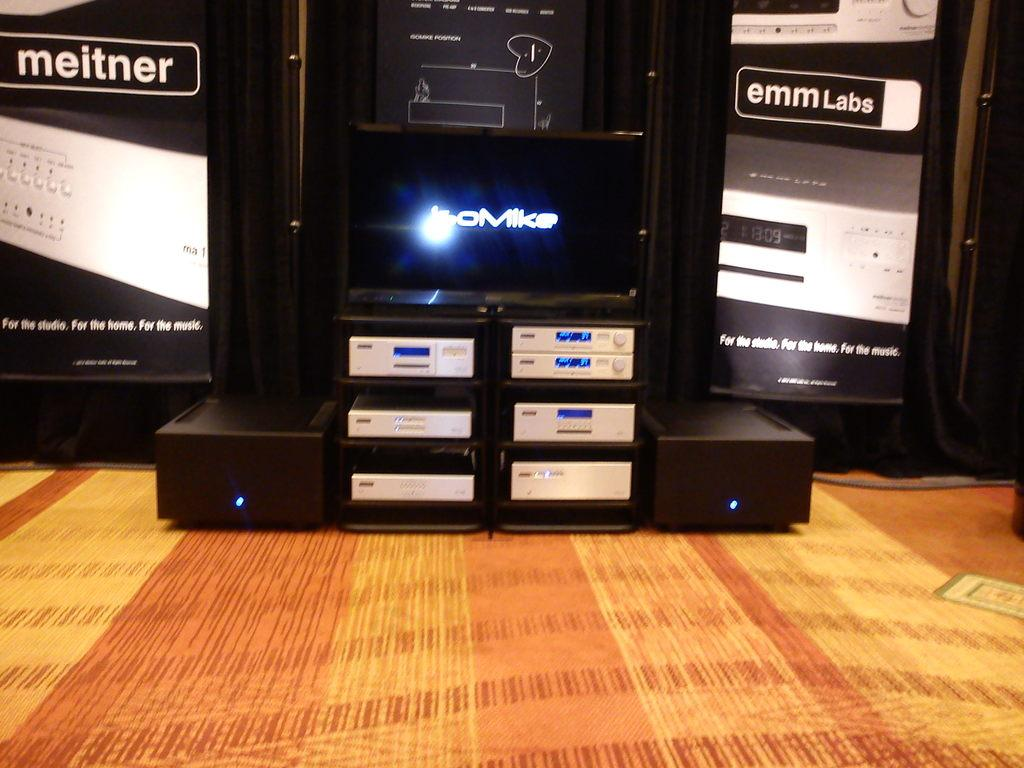What is located in the foreground of the image? There is a mat in the foreground of the image. What type of objects can be seen in the image? There are electronic gadgets in the image. What is the cow's tendency in the image? There is no cow present in the image, so it is not possible to determine any tendencies. 